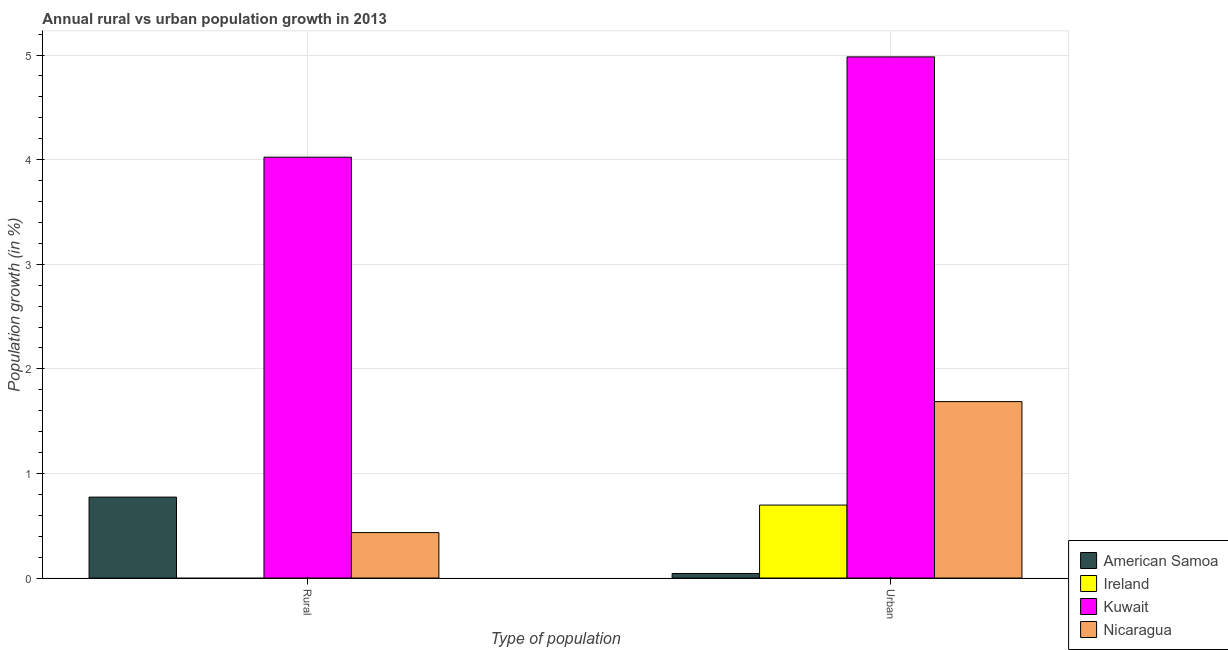Are the number of bars per tick equal to the number of legend labels?
Make the answer very short. No. How many bars are there on the 1st tick from the left?
Ensure brevity in your answer.  3. How many bars are there on the 2nd tick from the right?
Your answer should be compact. 3. What is the label of the 1st group of bars from the left?
Your response must be concise. Rural. What is the rural population growth in Kuwait?
Your answer should be compact. 4.02. Across all countries, what is the maximum urban population growth?
Your answer should be very brief. 4.98. In which country was the urban population growth maximum?
Ensure brevity in your answer.  Kuwait. What is the total rural population growth in the graph?
Make the answer very short. 5.23. What is the difference between the urban population growth in Kuwait and that in Ireland?
Keep it short and to the point. 4.28. What is the difference between the rural population growth in American Samoa and the urban population growth in Ireland?
Keep it short and to the point. 0.08. What is the average urban population growth per country?
Give a very brief answer. 1.85. What is the difference between the urban population growth and rural population growth in Nicaragua?
Ensure brevity in your answer.  1.25. What is the ratio of the urban population growth in Ireland to that in Kuwait?
Your response must be concise. 0.14. Is the urban population growth in Nicaragua less than that in Kuwait?
Provide a succinct answer. Yes. How many bars are there?
Ensure brevity in your answer.  7. How many countries are there in the graph?
Provide a succinct answer. 4. What is the difference between two consecutive major ticks on the Y-axis?
Offer a very short reply. 1. Does the graph contain any zero values?
Provide a short and direct response. Yes. Where does the legend appear in the graph?
Provide a short and direct response. Bottom right. How are the legend labels stacked?
Provide a succinct answer. Vertical. What is the title of the graph?
Your answer should be very brief. Annual rural vs urban population growth in 2013. What is the label or title of the X-axis?
Your answer should be compact. Type of population. What is the label or title of the Y-axis?
Provide a succinct answer. Population growth (in %). What is the Population growth (in %) of American Samoa in Rural?
Keep it short and to the point. 0.77. What is the Population growth (in %) of Kuwait in Rural?
Make the answer very short. 4.02. What is the Population growth (in %) in Nicaragua in Rural?
Keep it short and to the point. 0.43. What is the Population growth (in %) in American Samoa in Urban ?
Provide a succinct answer. 0.04. What is the Population growth (in %) in Ireland in Urban ?
Make the answer very short. 0.7. What is the Population growth (in %) of Kuwait in Urban ?
Keep it short and to the point. 4.98. What is the Population growth (in %) of Nicaragua in Urban ?
Your answer should be compact. 1.69. Across all Type of population, what is the maximum Population growth (in %) in American Samoa?
Your answer should be very brief. 0.77. Across all Type of population, what is the maximum Population growth (in %) of Ireland?
Your response must be concise. 0.7. Across all Type of population, what is the maximum Population growth (in %) of Kuwait?
Provide a succinct answer. 4.98. Across all Type of population, what is the maximum Population growth (in %) of Nicaragua?
Keep it short and to the point. 1.69. Across all Type of population, what is the minimum Population growth (in %) of American Samoa?
Offer a very short reply. 0.04. Across all Type of population, what is the minimum Population growth (in %) of Kuwait?
Provide a succinct answer. 4.02. Across all Type of population, what is the minimum Population growth (in %) of Nicaragua?
Your response must be concise. 0.43. What is the total Population growth (in %) of American Samoa in the graph?
Keep it short and to the point. 0.82. What is the total Population growth (in %) of Ireland in the graph?
Give a very brief answer. 0.7. What is the total Population growth (in %) of Kuwait in the graph?
Your answer should be compact. 9.01. What is the total Population growth (in %) in Nicaragua in the graph?
Make the answer very short. 2.12. What is the difference between the Population growth (in %) in American Samoa in Rural and that in Urban ?
Provide a succinct answer. 0.73. What is the difference between the Population growth (in %) in Kuwait in Rural and that in Urban ?
Offer a very short reply. -0.96. What is the difference between the Population growth (in %) of Nicaragua in Rural and that in Urban ?
Make the answer very short. -1.25. What is the difference between the Population growth (in %) in American Samoa in Rural and the Population growth (in %) in Ireland in Urban?
Offer a terse response. 0.08. What is the difference between the Population growth (in %) in American Samoa in Rural and the Population growth (in %) in Kuwait in Urban?
Offer a terse response. -4.21. What is the difference between the Population growth (in %) of American Samoa in Rural and the Population growth (in %) of Nicaragua in Urban?
Keep it short and to the point. -0.91. What is the difference between the Population growth (in %) in Kuwait in Rural and the Population growth (in %) in Nicaragua in Urban?
Provide a succinct answer. 2.34. What is the average Population growth (in %) of American Samoa per Type of population?
Your response must be concise. 0.41. What is the average Population growth (in %) in Ireland per Type of population?
Your response must be concise. 0.35. What is the average Population growth (in %) of Kuwait per Type of population?
Ensure brevity in your answer.  4.5. What is the average Population growth (in %) of Nicaragua per Type of population?
Your answer should be very brief. 1.06. What is the difference between the Population growth (in %) of American Samoa and Population growth (in %) of Kuwait in Rural?
Your response must be concise. -3.25. What is the difference between the Population growth (in %) in American Samoa and Population growth (in %) in Nicaragua in Rural?
Offer a terse response. 0.34. What is the difference between the Population growth (in %) in Kuwait and Population growth (in %) in Nicaragua in Rural?
Keep it short and to the point. 3.59. What is the difference between the Population growth (in %) of American Samoa and Population growth (in %) of Ireland in Urban ?
Your answer should be very brief. -0.65. What is the difference between the Population growth (in %) of American Samoa and Population growth (in %) of Kuwait in Urban ?
Provide a succinct answer. -4.94. What is the difference between the Population growth (in %) in American Samoa and Population growth (in %) in Nicaragua in Urban ?
Provide a succinct answer. -1.64. What is the difference between the Population growth (in %) in Ireland and Population growth (in %) in Kuwait in Urban ?
Make the answer very short. -4.28. What is the difference between the Population growth (in %) of Ireland and Population growth (in %) of Nicaragua in Urban ?
Your answer should be compact. -0.99. What is the difference between the Population growth (in %) in Kuwait and Population growth (in %) in Nicaragua in Urban ?
Provide a short and direct response. 3.3. What is the ratio of the Population growth (in %) of American Samoa in Rural to that in Urban ?
Offer a terse response. 17.79. What is the ratio of the Population growth (in %) of Kuwait in Rural to that in Urban ?
Ensure brevity in your answer.  0.81. What is the ratio of the Population growth (in %) in Nicaragua in Rural to that in Urban ?
Provide a succinct answer. 0.26. What is the difference between the highest and the second highest Population growth (in %) of American Samoa?
Make the answer very short. 0.73. What is the difference between the highest and the second highest Population growth (in %) of Kuwait?
Provide a succinct answer. 0.96. What is the difference between the highest and the second highest Population growth (in %) of Nicaragua?
Keep it short and to the point. 1.25. What is the difference between the highest and the lowest Population growth (in %) in American Samoa?
Make the answer very short. 0.73. What is the difference between the highest and the lowest Population growth (in %) of Ireland?
Keep it short and to the point. 0.7. What is the difference between the highest and the lowest Population growth (in %) in Kuwait?
Give a very brief answer. 0.96. What is the difference between the highest and the lowest Population growth (in %) in Nicaragua?
Offer a very short reply. 1.25. 